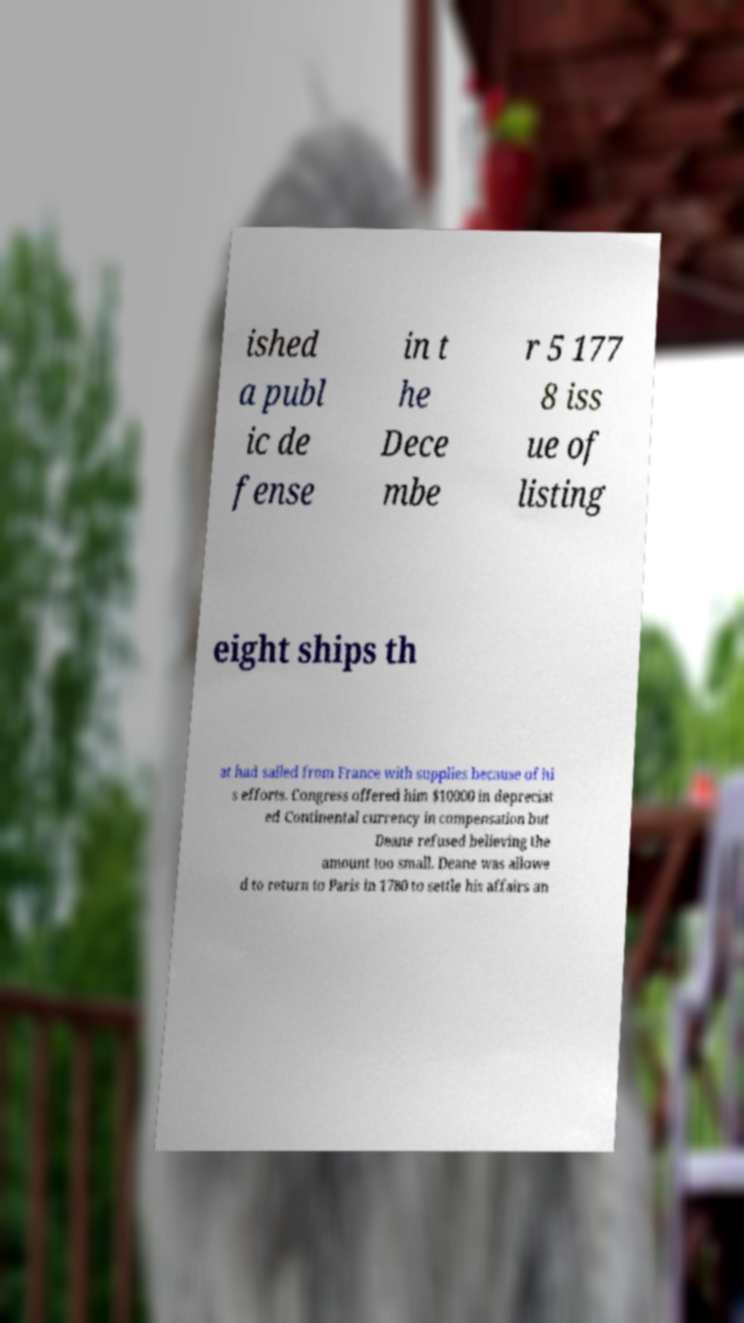For documentation purposes, I need the text within this image transcribed. Could you provide that? ished a publ ic de fense in t he Dece mbe r 5 177 8 iss ue of listing eight ships th at had sailed from France with supplies because of hi s efforts. Congress offered him $10000 in depreciat ed Continental currency in compensation but Deane refused believing the amount too small. Deane was allowe d to return to Paris in 1780 to settle his affairs an 